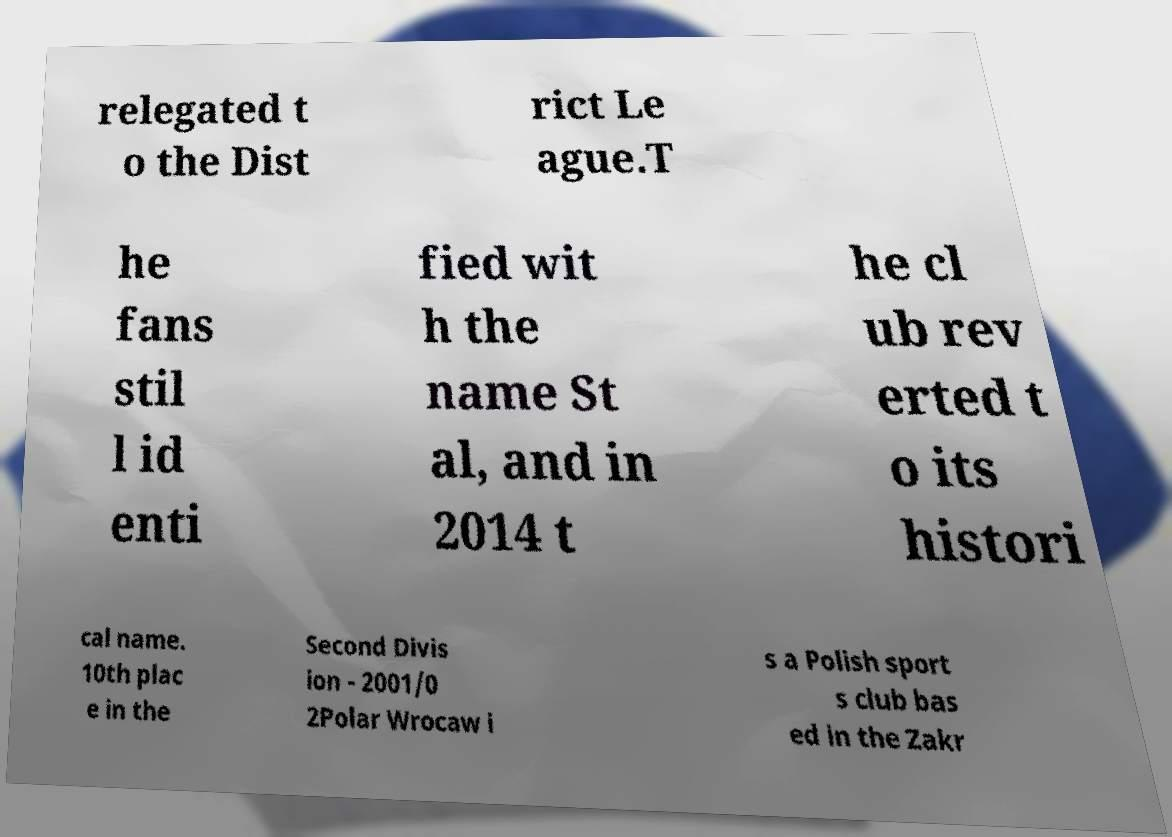Can you read and provide the text displayed in the image?This photo seems to have some interesting text. Can you extract and type it out for me? relegated t o the Dist rict Le ague.T he fans stil l id enti fied wit h the name St al, and in 2014 t he cl ub rev erted t o its histori cal name. 10th plac e in the Second Divis ion - 2001/0 2Polar Wrocaw i s a Polish sport s club bas ed in the Zakr 